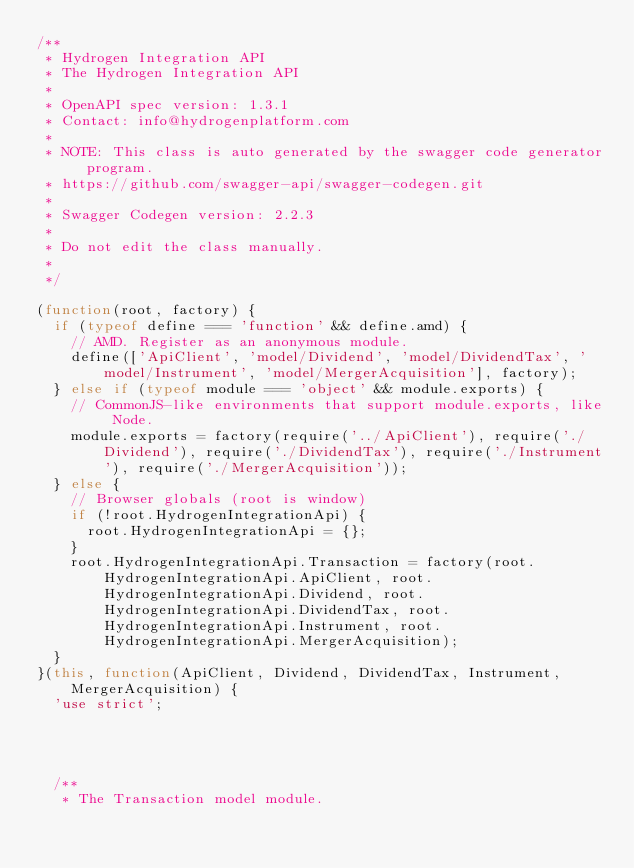Convert code to text. <code><loc_0><loc_0><loc_500><loc_500><_JavaScript_>/**
 * Hydrogen Integration API
 * The Hydrogen Integration API
 *
 * OpenAPI spec version: 1.3.1
 * Contact: info@hydrogenplatform.com
 *
 * NOTE: This class is auto generated by the swagger code generator program.
 * https://github.com/swagger-api/swagger-codegen.git
 *
 * Swagger Codegen version: 2.2.3
 *
 * Do not edit the class manually.
 *
 */

(function(root, factory) {
  if (typeof define === 'function' && define.amd) {
    // AMD. Register as an anonymous module.
    define(['ApiClient', 'model/Dividend', 'model/DividendTax', 'model/Instrument', 'model/MergerAcquisition'], factory);
  } else if (typeof module === 'object' && module.exports) {
    // CommonJS-like environments that support module.exports, like Node.
    module.exports = factory(require('../ApiClient'), require('./Dividend'), require('./DividendTax'), require('./Instrument'), require('./MergerAcquisition'));
  } else {
    // Browser globals (root is window)
    if (!root.HydrogenIntegrationApi) {
      root.HydrogenIntegrationApi = {};
    }
    root.HydrogenIntegrationApi.Transaction = factory(root.HydrogenIntegrationApi.ApiClient, root.HydrogenIntegrationApi.Dividend, root.HydrogenIntegrationApi.DividendTax, root.HydrogenIntegrationApi.Instrument, root.HydrogenIntegrationApi.MergerAcquisition);
  }
}(this, function(ApiClient, Dividend, DividendTax, Instrument, MergerAcquisition) {
  'use strict';




  /**
   * The Transaction model module.</code> 